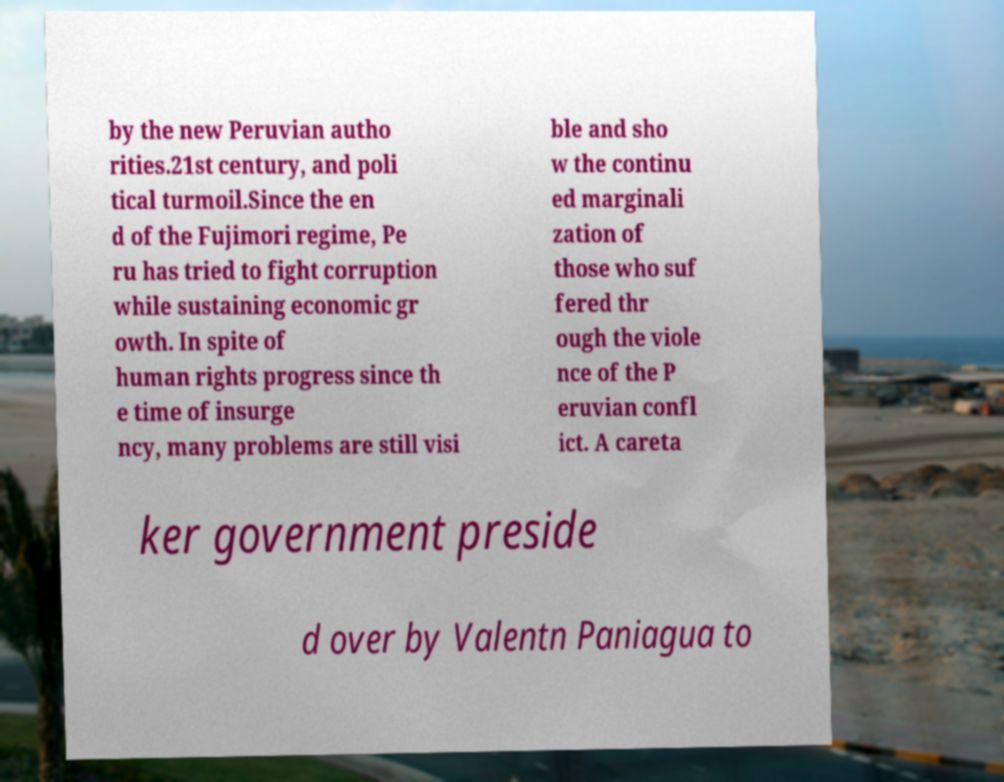For documentation purposes, I need the text within this image transcribed. Could you provide that? by the new Peruvian autho rities.21st century, and poli tical turmoil.Since the en d of the Fujimori regime, Pe ru has tried to fight corruption while sustaining economic gr owth. In spite of human rights progress since th e time of insurge ncy, many problems are still visi ble and sho w the continu ed marginali zation of those who suf fered thr ough the viole nce of the P eruvian confl ict. A careta ker government preside d over by Valentn Paniagua to 